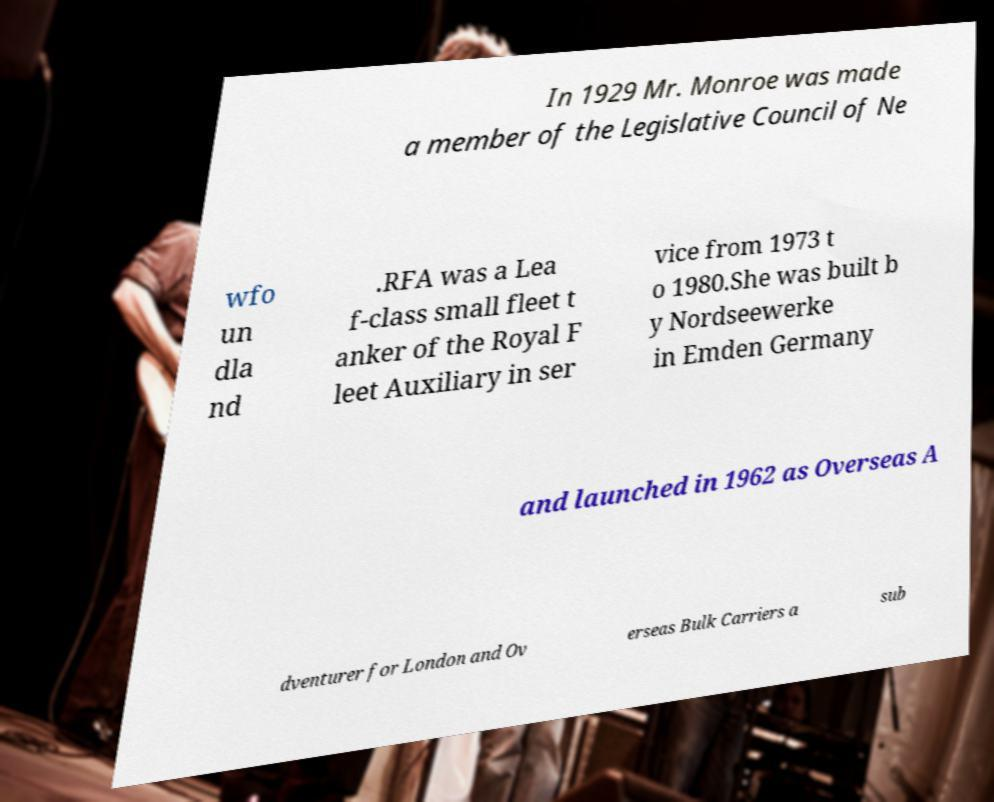Please read and relay the text visible in this image. What does it say? In 1929 Mr. Monroe was made a member of the Legislative Council of Ne wfo un dla nd .RFA was a Lea f-class small fleet t anker of the Royal F leet Auxiliary in ser vice from 1973 t o 1980.She was built b y Nordseewerke in Emden Germany and launched in 1962 as Overseas A dventurer for London and Ov erseas Bulk Carriers a sub 